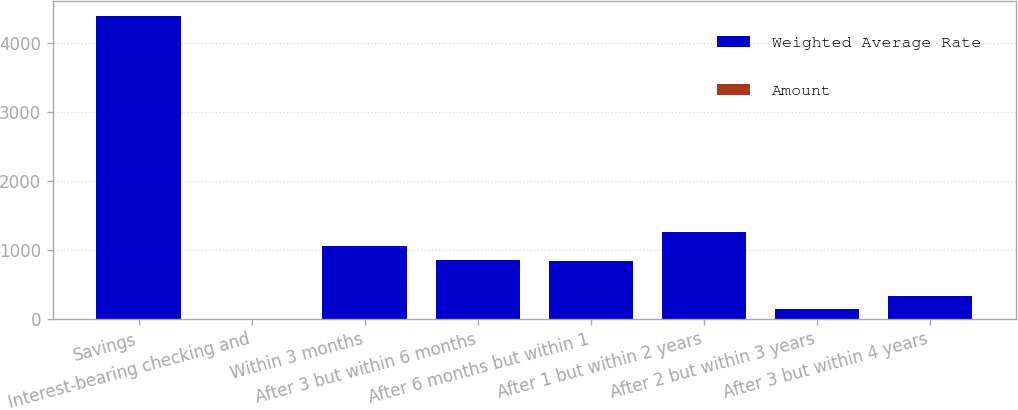<chart> <loc_0><loc_0><loc_500><loc_500><stacked_bar_chart><ecel><fcel>Savings<fcel>Interest-bearing checking and<fcel>Within 3 months<fcel>After 3 but within 6 months<fcel>After 6 months but within 1<fcel>After 1 but within 2 years<fcel>After 2 but within 3 years<fcel>After 3 but within 4 years<nl><fcel>Weighted Average Rate<fcel>4397.7<fcel>1.81<fcel>1054.9<fcel>852.4<fcel>835.2<fcel>1256.3<fcel>142.7<fcel>335.1<nl><fcel>Amount<fcel>0.14<fcel>0.27<fcel>0.7<fcel>0.75<fcel>0.75<fcel>1.09<fcel>1.26<fcel>1.81<nl></chart> 